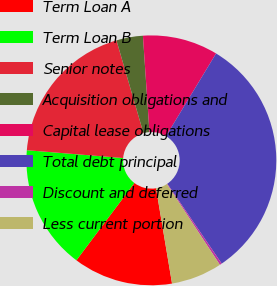Convert chart to OTSL. <chart><loc_0><loc_0><loc_500><loc_500><pie_chart><fcel>Term Loan A<fcel>Term Loan B<fcel>Senior notes<fcel>Acquisition obligations and<fcel>Capital lease obligations<fcel>Total debt principal<fcel>Discount and deferred<fcel>Less current portion<nl><fcel>12.89%<fcel>16.05%<fcel>19.2%<fcel>3.43%<fcel>9.74%<fcel>31.82%<fcel>0.28%<fcel>6.59%<nl></chart> 